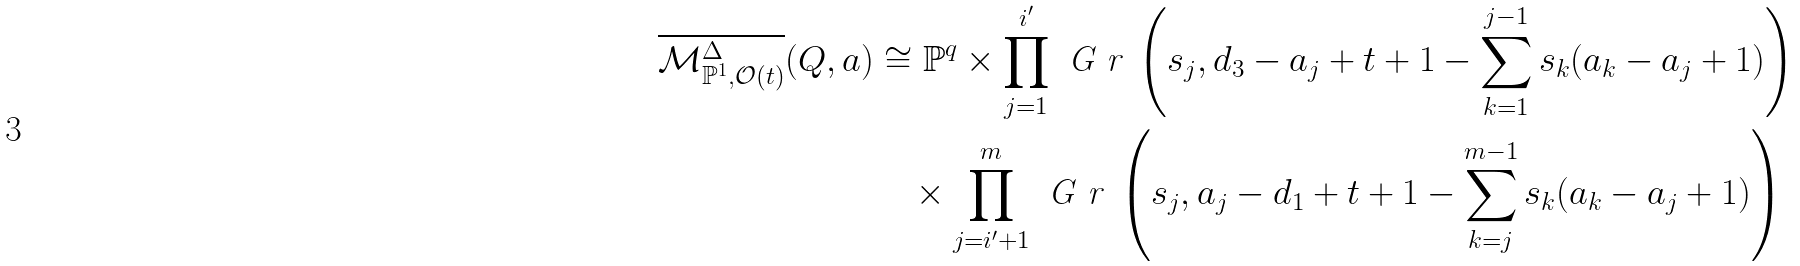<formula> <loc_0><loc_0><loc_500><loc_500>\overline { \mathcal { M } ^ { \Delta } _ { \mathbb { P } ^ { 1 } , \mathcal { O } ( t ) } } ( Q , a ) & \cong \mathbb { P } ^ { q } \times \prod _ { j = 1 } ^ { i ^ { \prime } } \emph { G r } \left ( s _ { j } , d _ { 3 } - a _ { j } + t + 1 - \sum _ { k = 1 } ^ { j - 1 } s _ { k } ( a _ { k } - a _ { j } + 1 ) \right ) \\ & \quad \times \prod _ { j = i ^ { \prime } + 1 } ^ { m } \emph { G r } \left ( s _ { j } , a _ { j } - d _ { 1 } + t + 1 - \sum _ { k = j } ^ { m - 1 } s _ { k } ( a _ { k } - a _ { j } + 1 ) \right )</formula> 